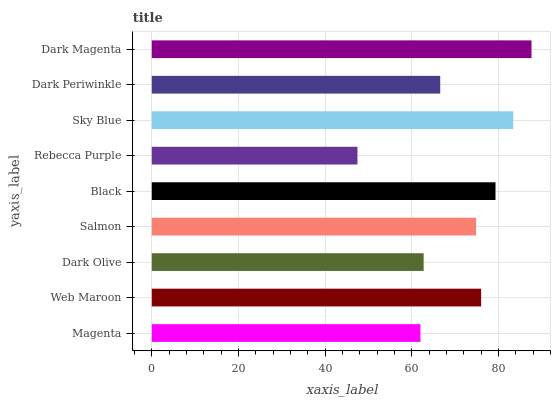Is Rebecca Purple the minimum?
Answer yes or no. Yes. Is Dark Magenta the maximum?
Answer yes or no. Yes. Is Web Maroon the minimum?
Answer yes or no. No. Is Web Maroon the maximum?
Answer yes or no. No. Is Web Maroon greater than Magenta?
Answer yes or no. Yes. Is Magenta less than Web Maroon?
Answer yes or no. Yes. Is Magenta greater than Web Maroon?
Answer yes or no. No. Is Web Maroon less than Magenta?
Answer yes or no. No. Is Salmon the high median?
Answer yes or no. Yes. Is Salmon the low median?
Answer yes or no. Yes. Is Dark Magenta the high median?
Answer yes or no. No. Is Sky Blue the low median?
Answer yes or no. No. 